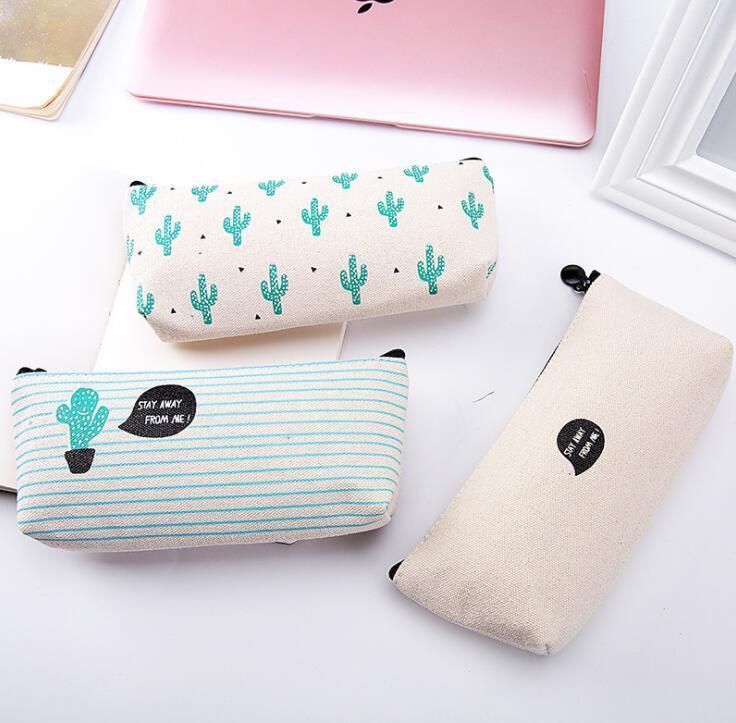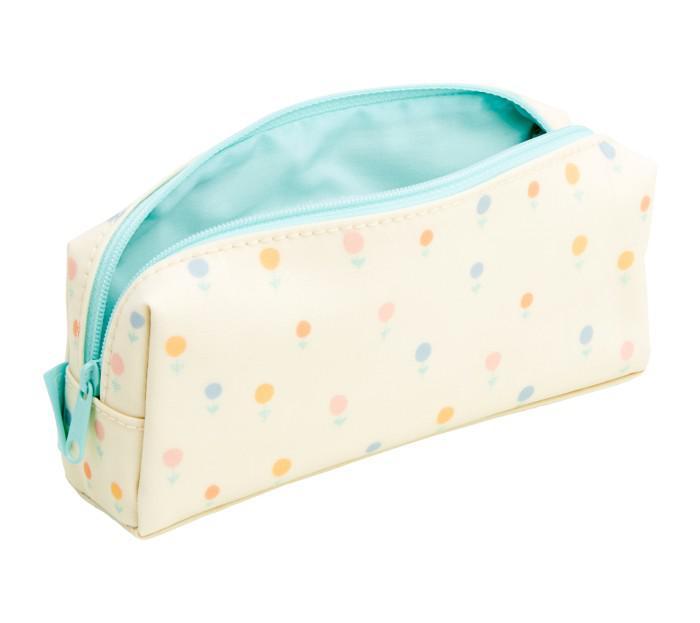The first image is the image on the left, the second image is the image on the right. Analyze the images presented: Is the assertion "One pencil case is unzipped and at least three are closed." valid? Answer yes or no. Yes. The first image is the image on the left, the second image is the image on the right. Examine the images to the left and right. Is the description "One image shows just one pencil case, which has eyes." accurate? Answer yes or no. No. 